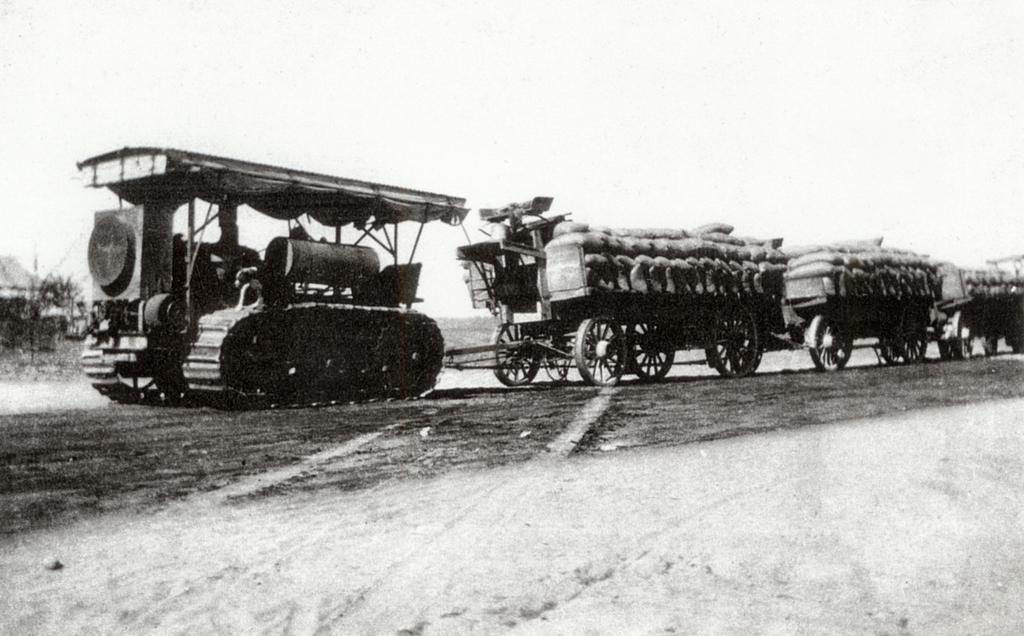In one or two sentences, can you explain what this image depicts? Here we can see a black and white photograph, in this we can see a vehicle and few bags. 